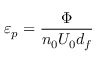<formula> <loc_0><loc_0><loc_500><loc_500>\varepsilon _ { p } = \frac { \Phi } { n _ { 0 } U _ { 0 } d _ { f } }</formula> 